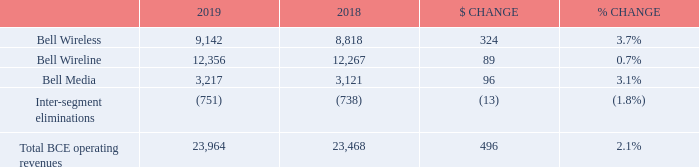4.3 Operating revenues
BCE
BCE operating revenues grew by 2.1% in 2019, compared to last year, driven by growth across all three of our segments. Total operating revenues consisted of service revenues of $20,737 million and product revenues of $3,227 million in 2019, up 1.4% and 6.6%, respectively, year over year. Wireless operating revenues grew by 3.7% in 2019, driven by product revenue growth of 6.6% and service revenue growth of 2.5%. Wireline operating revenues grew by 0.7% in 2019 attributable to service revenue growth of 0.4% from higher data revenue, moderated by lower voice revenue, and also reflected higher product revenue of 7.2%. Bell Media revenues increased by 3.1% in 2019 reflecting both higher subscriber and advertising revenues
What is the percentage change in the Total BCE operating revenues in 2019? 2.1%. How much did the wireless operating revenues grow by in 2019? 3.7%. What is the amount of $ CHANGE for Bell Wireless in 2019? 324. What is the percentage of operating revenues for Bell Media out of the total BCE operating revenues in 2019?
Answer scale should be: percent. 3,217/23,964
Answer: 13.42. What is the sum of revenues for Bell Wireless and Bell Wireline in 2018? 8,818+12,267
Answer: 21085. What is the total amount of revenue for Bell Media in 2018 and 2019? 3,217+3,121
Answer: 6338. 